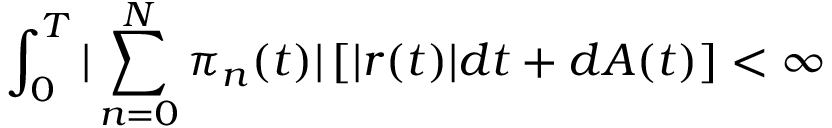<formula> <loc_0><loc_0><loc_500><loc_500>\int _ { 0 } ^ { T } | \sum _ { n = 0 } ^ { N } \pi _ { n } ( t ) | \left [ | r ( t ) | d t + d A ( t ) \right ] < \infty</formula> 